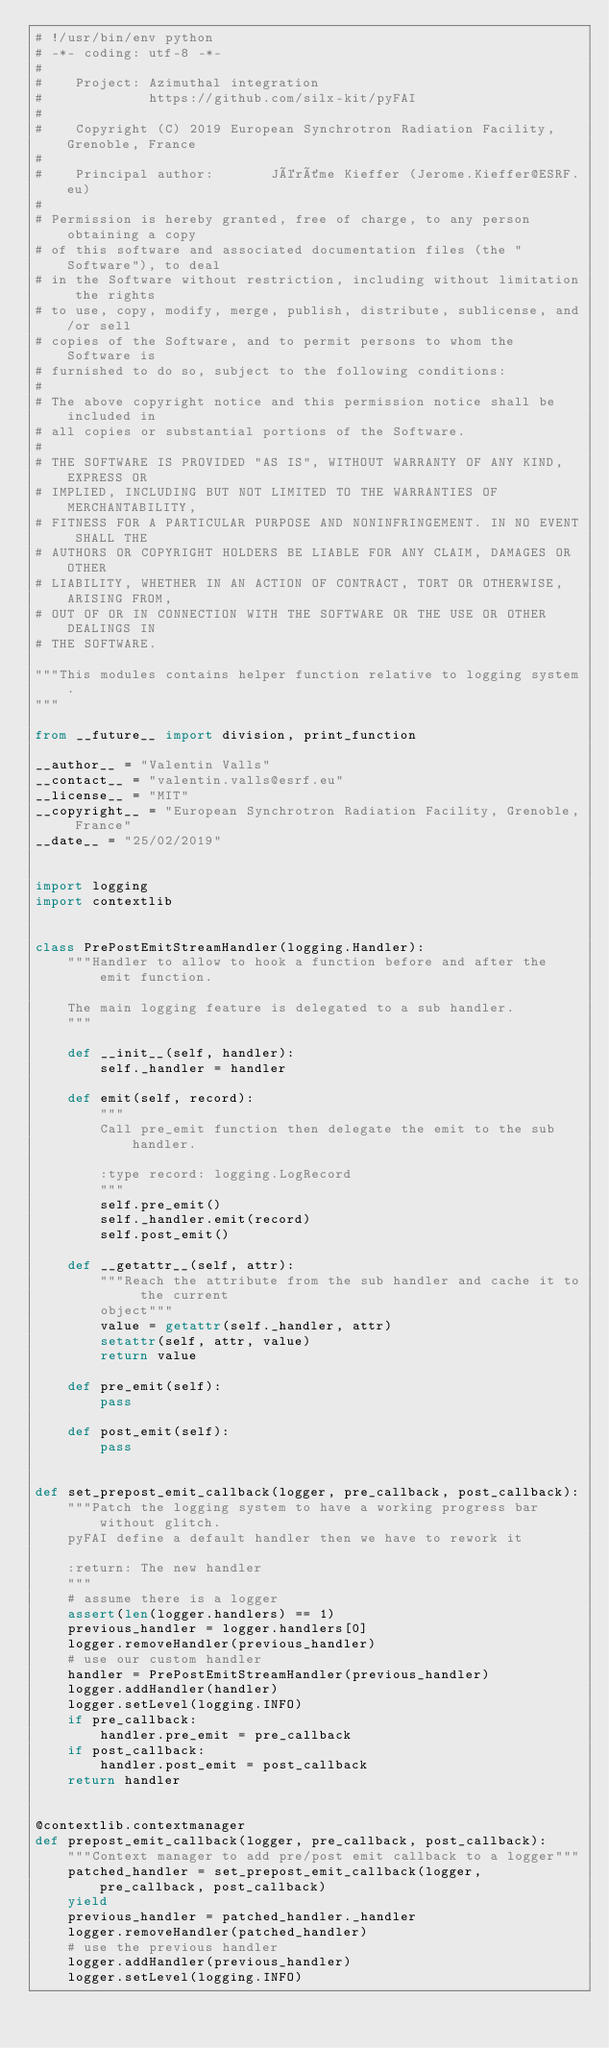<code> <loc_0><loc_0><loc_500><loc_500><_Python_># !/usr/bin/env python
# -*- coding: utf-8 -*-
#
#    Project: Azimuthal integration
#             https://github.com/silx-kit/pyFAI
#
#    Copyright (C) 2019 European Synchrotron Radiation Facility, Grenoble, France
#
#    Principal author:       Jérôme Kieffer (Jerome.Kieffer@ESRF.eu)
#
# Permission is hereby granted, free of charge, to any person obtaining a copy
# of this software and associated documentation files (the "Software"), to deal
# in the Software without restriction, including without limitation the rights
# to use, copy, modify, merge, publish, distribute, sublicense, and/or sell
# copies of the Software, and to permit persons to whom the Software is
# furnished to do so, subject to the following conditions:
#
# The above copyright notice and this permission notice shall be included in
# all copies or substantial portions of the Software.
#
# THE SOFTWARE IS PROVIDED "AS IS", WITHOUT WARRANTY OF ANY KIND, EXPRESS OR
# IMPLIED, INCLUDING BUT NOT LIMITED TO THE WARRANTIES OF MERCHANTABILITY,
# FITNESS FOR A PARTICULAR PURPOSE AND NONINFRINGEMENT. IN NO EVENT SHALL THE
# AUTHORS OR COPYRIGHT HOLDERS BE LIABLE FOR ANY CLAIM, DAMAGES OR OTHER
# LIABILITY, WHETHER IN AN ACTION OF CONTRACT, TORT OR OTHERWISE, ARISING FROM,
# OUT OF OR IN CONNECTION WITH THE SOFTWARE OR THE USE OR OTHER DEALINGS IN
# THE SOFTWARE.

"""This modules contains helper function relative to logging system.
"""

from __future__ import division, print_function

__author__ = "Valentin Valls"
__contact__ = "valentin.valls@esrf.eu"
__license__ = "MIT"
__copyright__ = "European Synchrotron Radiation Facility, Grenoble, France"
__date__ = "25/02/2019"


import logging
import contextlib


class PrePostEmitStreamHandler(logging.Handler):
    """Handler to allow to hook a function before and after the emit function.

    The main logging feature is delegated to a sub handler.
    """

    def __init__(self, handler):
        self._handler = handler

    def emit(self, record):
        """
        Call pre_emit function then delegate the emit to the sub handler.

        :type record: logging.LogRecord
        """
        self.pre_emit()
        self._handler.emit(record)
        self.post_emit()

    def __getattr__(self, attr):
        """Reach the attribute from the sub handler and cache it to the current
        object"""
        value = getattr(self._handler, attr)
        setattr(self, attr, value)
        return value

    def pre_emit(self):
        pass

    def post_emit(self):
        pass


def set_prepost_emit_callback(logger, pre_callback, post_callback):
    """Patch the logging system to have a working progress bar without glitch.
    pyFAI define a default handler then we have to rework it

    :return: The new handler
    """
    # assume there is a logger
    assert(len(logger.handlers) == 1)
    previous_handler = logger.handlers[0]
    logger.removeHandler(previous_handler)
    # use our custom handler
    handler = PrePostEmitStreamHandler(previous_handler)
    logger.addHandler(handler)
    logger.setLevel(logging.INFO)
    if pre_callback:
        handler.pre_emit = pre_callback
    if post_callback:
        handler.post_emit = post_callback
    return handler


@contextlib.contextmanager
def prepost_emit_callback(logger, pre_callback, post_callback):
    """Context manager to add pre/post emit callback to a logger"""
    patched_handler = set_prepost_emit_callback(logger, pre_callback, post_callback)
    yield
    previous_handler = patched_handler._handler
    logger.removeHandler(patched_handler)
    # use the previous handler
    logger.addHandler(previous_handler)
    logger.setLevel(logging.INFO)
</code> 